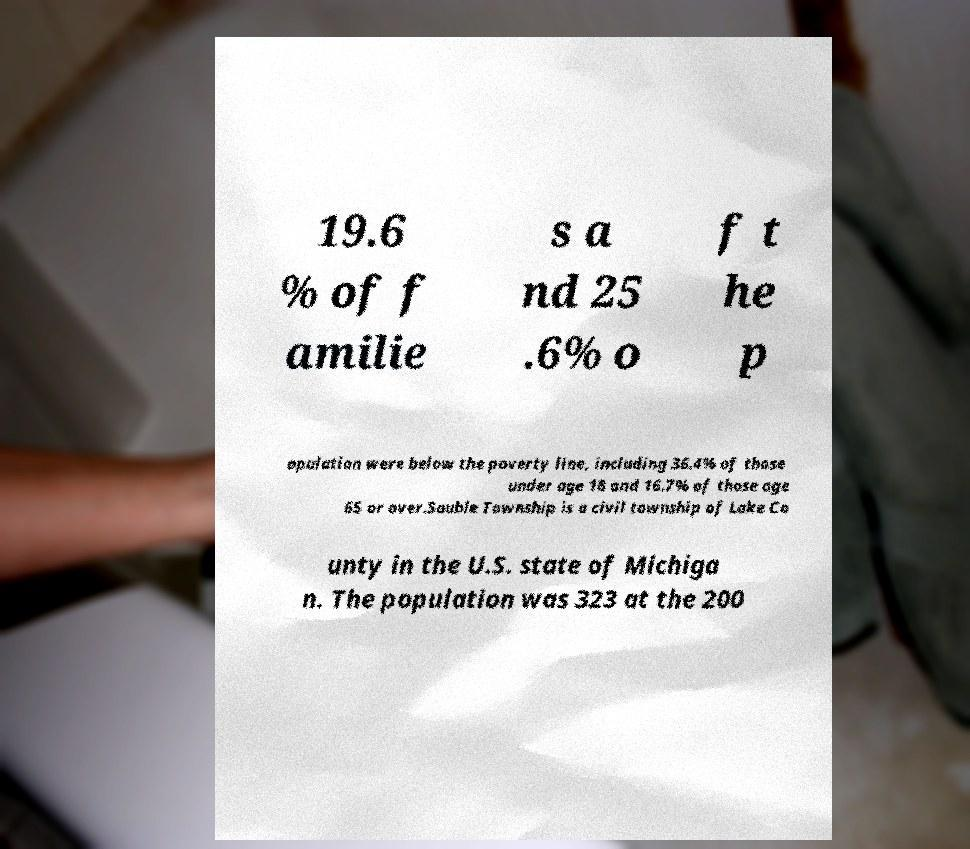For documentation purposes, I need the text within this image transcribed. Could you provide that? 19.6 % of f amilie s a nd 25 .6% o f t he p opulation were below the poverty line, including 36.4% of those under age 18 and 16.7% of those age 65 or over.Sauble Township is a civil township of Lake Co unty in the U.S. state of Michiga n. The population was 323 at the 200 